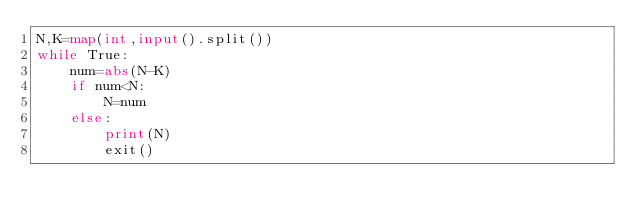<code> <loc_0><loc_0><loc_500><loc_500><_Python_>N,K=map(int,input().split())
while True:
    num=abs(N-K)
    if num<N:
        N=num
    else:
        print(N)
        exit()
</code> 